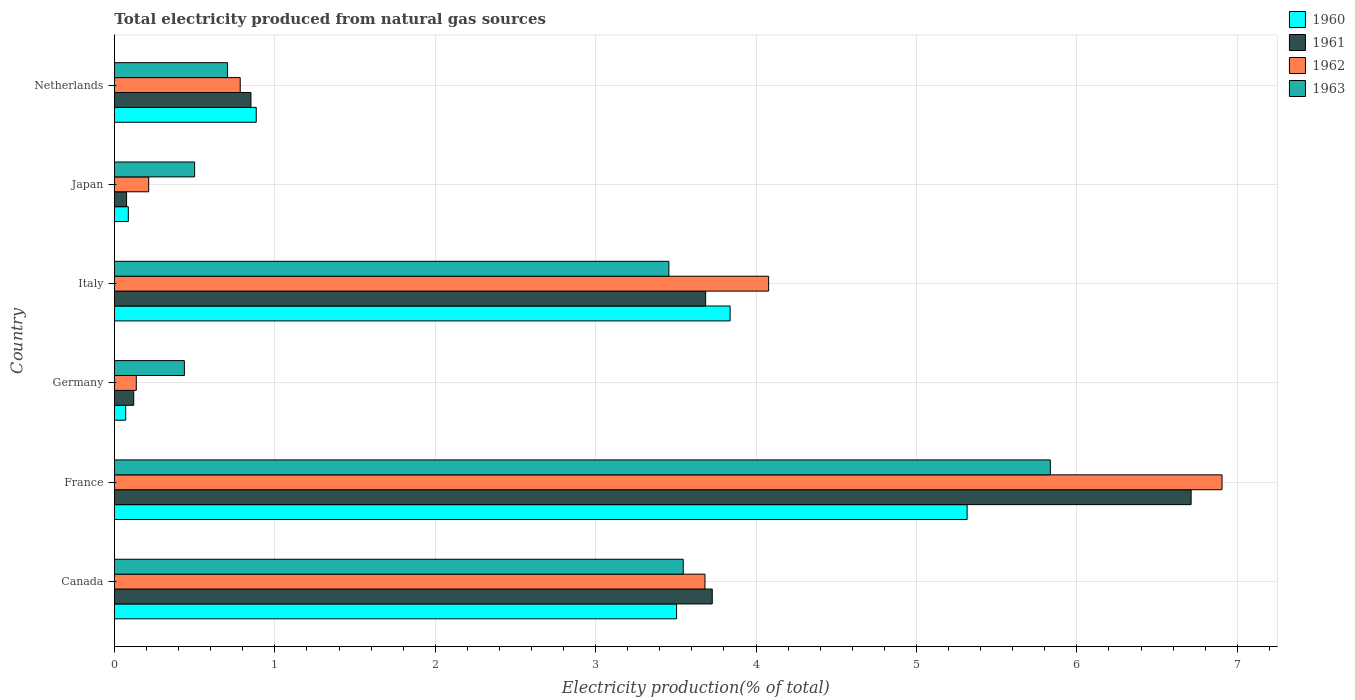How many groups of bars are there?
Your response must be concise. 6. Are the number of bars per tick equal to the number of legend labels?
Make the answer very short. Yes. Are the number of bars on each tick of the Y-axis equal?
Ensure brevity in your answer.  Yes. What is the total electricity produced in 1961 in France?
Make the answer very short. 6.71. Across all countries, what is the maximum total electricity produced in 1960?
Offer a terse response. 5.32. Across all countries, what is the minimum total electricity produced in 1962?
Provide a succinct answer. 0.14. In which country was the total electricity produced in 1960 maximum?
Make the answer very short. France. In which country was the total electricity produced in 1963 minimum?
Provide a short and direct response. Germany. What is the total total electricity produced in 1963 in the graph?
Provide a succinct answer. 14.48. What is the difference between the total electricity produced in 1962 in France and that in Italy?
Provide a short and direct response. 2.83. What is the difference between the total electricity produced in 1963 in France and the total electricity produced in 1961 in Canada?
Your answer should be very brief. 2.11. What is the average total electricity produced in 1961 per country?
Give a very brief answer. 2.53. What is the difference between the total electricity produced in 1960 and total electricity produced in 1962 in Japan?
Provide a succinct answer. -0.13. What is the ratio of the total electricity produced in 1961 in Germany to that in Netherlands?
Make the answer very short. 0.14. Is the total electricity produced in 1962 in Canada less than that in France?
Provide a short and direct response. Yes. Is the difference between the total electricity produced in 1960 in Canada and Italy greater than the difference between the total electricity produced in 1962 in Canada and Italy?
Make the answer very short. Yes. What is the difference between the highest and the second highest total electricity produced in 1960?
Your answer should be compact. 1.48. What is the difference between the highest and the lowest total electricity produced in 1963?
Provide a short and direct response. 5.4. What does the 4th bar from the top in Italy represents?
Your response must be concise. 1960. Are all the bars in the graph horizontal?
Your answer should be compact. Yes. Does the graph contain any zero values?
Provide a short and direct response. No. Where does the legend appear in the graph?
Provide a succinct answer. Top right. How many legend labels are there?
Provide a short and direct response. 4. How are the legend labels stacked?
Provide a succinct answer. Vertical. What is the title of the graph?
Keep it short and to the point. Total electricity produced from natural gas sources. Does "1994" appear as one of the legend labels in the graph?
Ensure brevity in your answer.  No. What is the label or title of the X-axis?
Make the answer very short. Electricity production(% of total). What is the label or title of the Y-axis?
Keep it short and to the point. Country. What is the Electricity production(% of total) in 1960 in Canada?
Your response must be concise. 3.5. What is the Electricity production(% of total) in 1961 in Canada?
Offer a terse response. 3.73. What is the Electricity production(% of total) in 1962 in Canada?
Your answer should be very brief. 3.68. What is the Electricity production(% of total) of 1963 in Canada?
Offer a very short reply. 3.55. What is the Electricity production(% of total) in 1960 in France?
Give a very brief answer. 5.32. What is the Electricity production(% of total) in 1961 in France?
Your response must be concise. 6.71. What is the Electricity production(% of total) in 1962 in France?
Keep it short and to the point. 6.91. What is the Electricity production(% of total) in 1963 in France?
Offer a terse response. 5.83. What is the Electricity production(% of total) in 1960 in Germany?
Provide a short and direct response. 0.07. What is the Electricity production(% of total) in 1961 in Germany?
Your answer should be compact. 0.12. What is the Electricity production(% of total) in 1962 in Germany?
Make the answer very short. 0.14. What is the Electricity production(% of total) of 1963 in Germany?
Your answer should be very brief. 0.44. What is the Electricity production(% of total) in 1960 in Italy?
Your response must be concise. 3.84. What is the Electricity production(% of total) in 1961 in Italy?
Your answer should be compact. 3.69. What is the Electricity production(% of total) in 1962 in Italy?
Keep it short and to the point. 4.08. What is the Electricity production(% of total) in 1963 in Italy?
Offer a terse response. 3.46. What is the Electricity production(% of total) of 1960 in Japan?
Keep it short and to the point. 0.09. What is the Electricity production(% of total) of 1961 in Japan?
Offer a terse response. 0.08. What is the Electricity production(% of total) in 1962 in Japan?
Provide a short and direct response. 0.21. What is the Electricity production(% of total) of 1963 in Japan?
Give a very brief answer. 0.5. What is the Electricity production(% of total) of 1960 in Netherlands?
Ensure brevity in your answer.  0.88. What is the Electricity production(% of total) of 1961 in Netherlands?
Provide a short and direct response. 0.85. What is the Electricity production(% of total) in 1962 in Netherlands?
Offer a very short reply. 0.78. What is the Electricity production(% of total) of 1963 in Netherlands?
Provide a short and direct response. 0.71. Across all countries, what is the maximum Electricity production(% of total) of 1960?
Ensure brevity in your answer.  5.32. Across all countries, what is the maximum Electricity production(% of total) of 1961?
Your response must be concise. 6.71. Across all countries, what is the maximum Electricity production(% of total) in 1962?
Your response must be concise. 6.91. Across all countries, what is the maximum Electricity production(% of total) in 1963?
Your response must be concise. 5.83. Across all countries, what is the minimum Electricity production(% of total) in 1960?
Make the answer very short. 0.07. Across all countries, what is the minimum Electricity production(% of total) in 1961?
Provide a succinct answer. 0.08. Across all countries, what is the minimum Electricity production(% of total) in 1962?
Ensure brevity in your answer.  0.14. Across all countries, what is the minimum Electricity production(% of total) in 1963?
Offer a very short reply. 0.44. What is the total Electricity production(% of total) of 1960 in the graph?
Keep it short and to the point. 13.7. What is the total Electricity production(% of total) of 1961 in the graph?
Offer a very short reply. 15.17. What is the total Electricity production(% of total) in 1962 in the graph?
Keep it short and to the point. 15.8. What is the total Electricity production(% of total) of 1963 in the graph?
Your answer should be very brief. 14.48. What is the difference between the Electricity production(% of total) in 1960 in Canada and that in France?
Your response must be concise. -1.81. What is the difference between the Electricity production(% of total) in 1961 in Canada and that in France?
Make the answer very short. -2.99. What is the difference between the Electricity production(% of total) in 1962 in Canada and that in France?
Provide a succinct answer. -3.22. What is the difference between the Electricity production(% of total) in 1963 in Canada and that in France?
Ensure brevity in your answer.  -2.29. What is the difference between the Electricity production(% of total) of 1960 in Canada and that in Germany?
Offer a very short reply. 3.43. What is the difference between the Electricity production(% of total) in 1961 in Canada and that in Germany?
Give a very brief answer. 3.61. What is the difference between the Electricity production(% of total) of 1962 in Canada and that in Germany?
Offer a terse response. 3.55. What is the difference between the Electricity production(% of total) of 1963 in Canada and that in Germany?
Make the answer very short. 3.11. What is the difference between the Electricity production(% of total) in 1960 in Canada and that in Italy?
Keep it short and to the point. -0.33. What is the difference between the Electricity production(% of total) in 1961 in Canada and that in Italy?
Your response must be concise. 0.04. What is the difference between the Electricity production(% of total) of 1962 in Canada and that in Italy?
Provide a succinct answer. -0.4. What is the difference between the Electricity production(% of total) of 1963 in Canada and that in Italy?
Offer a very short reply. 0.09. What is the difference between the Electricity production(% of total) of 1960 in Canada and that in Japan?
Offer a terse response. 3.42. What is the difference between the Electricity production(% of total) of 1961 in Canada and that in Japan?
Make the answer very short. 3.65. What is the difference between the Electricity production(% of total) in 1962 in Canada and that in Japan?
Your answer should be compact. 3.47. What is the difference between the Electricity production(% of total) in 1963 in Canada and that in Japan?
Your response must be concise. 3.05. What is the difference between the Electricity production(% of total) in 1960 in Canada and that in Netherlands?
Provide a short and direct response. 2.62. What is the difference between the Electricity production(% of total) in 1961 in Canada and that in Netherlands?
Your response must be concise. 2.88. What is the difference between the Electricity production(% of total) in 1962 in Canada and that in Netherlands?
Offer a very short reply. 2.9. What is the difference between the Electricity production(% of total) in 1963 in Canada and that in Netherlands?
Make the answer very short. 2.84. What is the difference between the Electricity production(% of total) in 1960 in France and that in Germany?
Your answer should be compact. 5.25. What is the difference between the Electricity production(% of total) of 1961 in France and that in Germany?
Offer a very short reply. 6.59. What is the difference between the Electricity production(% of total) in 1962 in France and that in Germany?
Ensure brevity in your answer.  6.77. What is the difference between the Electricity production(% of total) in 1963 in France and that in Germany?
Make the answer very short. 5.4. What is the difference between the Electricity production(% of total) in 1960 in France and that in Italy?
Keep it short and to the point. 1.48. What is the difference between the Electricity production(% of total) of 1961 in France and that in Italy?
Offer a very short reply. 3.03. What is the difference between the Electricity production(% of total) of 1962 in France and that in Italy?
Give a very brief answer. 2.83. What is the difference between the Electricity production(% of total) of 1963 in France and that in Italy?
Your answer should be very brief. 2.38. What is the difference between the Electricity production(% of total) in 1960 in France and that in Japan?
Give a very brief answer. 5.23. What is the difference between the Electricity production(% of total) in 1961 in France and that in Japan?
Give a very brief answer. 6.64. What is the difference between the Electricity production(% of total) of 1962 in France and that in Japan?
Offer a very short reply. 6.69. What is the difference between the Electricity production(% of total) of 1963 in France and that in Japan?
Keep it short and to the point. 5.33. What is the difference between the Electricity production(% of total) of 1960 in France and that in Netherlands?
Make the answer very short. 4.43. What is the difference between the Electricity production(% of total) in 1961 in France and that in Netherlands?
Your response must be concise. 5.86. What is the difference between the Electricity production(% of total) in 1962 in France and that in Netherlands?
Your answer should be compact. 6.12. What is the difference between the Electricity production(% of total) in 1963 in France and that in Netherlands?
Your response must be concise. 5.13. What is the difference between the Electricity production(% of total) of 1960 in Germany and that in Italy?
Your answer should be compact. -3.77. What is the difference between the Electricity production(% of total) of 1961 in Germany and that in Italy?
Your response must be concise. -3.57. What is the difference between the Electricity production(% of total) in 1962 in Germany and that in Italy?
Your answer should be compact. -3.94. What is the difference between the Electricity production(% of total) of 1963 in Germany and that in Italy?
Your answer should be compact. -3.02. What is the difference between the Electricity production(% of total) of 1960 in Germany and that in Japan?
Offer a very short reply. -0.02. What is the difference between the Electricity production(% of total) in 1961 in Germany and that in Japan?
Keep it short and to the point. 0.04. What is the difference between the Electricity production(% of total) in 1962 in Germany and that in Japan?
Your response must be concise. -0.08. What is the difference between the Electricity production(% of total) of 1963 in Germany and that in Japan?
Give a very brief answer. -0.06. What is the difference between the Electricity production(% of total) of 1960 in Germany and that in Netherlands?
Provide a short and direct response. -0.81. What is the difference between the Electricity production(% of total) in 1961 in Germany and that in Netherlands?
Your response must be concise. -0.73. What is the difference between the Electricity production(% of total) in 1962 in Germany and that in Netherlands?
Your answer should be very brief. -0.65. What is the difference between the Electricity production(% of total) in 1963 in Germany and that in Netherlands?
Ensure brevity in your answer.  -0.27. What is the difference between the Electricity production(% of total) in 1960 in Italy and that in Japan?
Your response must be concise. 3.75. What is the difference between the Electricity production(% of total) of 1961 in Italy and that in Japan?
Give a very brief answer. 3.61. What is the difference between the Electricity production(% of total) of 1962 in Italy and that in Japan?
Keep it short and to the point. 3.86. What is the difference between the Electricity production(% of total) in 1963 in Italy and that in Japan?
Keep it short and to the point. 2.96. What is the difference between the Electricity production(% of total) in 1960 in Italy and that in Netherlands?
Your response must be concise. 2.95. What is the difference between the Electricity production(% of total) of 1961 in Italy and that in Netherlands?
Keep it short and to the point. 2.83. What is the difference between the Electricity production(% of total) in 1962 in Italy and that in Netherlands?
Offer a terse response. 3.29. What is the difference between the Electricity production(% of total) of 1963 in Italy and that in Netherlands?
Ensure brevity in your answer.  2.75. What is the difference between the Electricity production(% of total) in 1960 in Japan and that in Netherlands?
Offer a very short reply. -0.8. What is the difference between the Electricity production(% of total) in 1961 in Japan and that in Netherlands?
Your answer should be very brief. -0.78. What is the difference between the Electricity production(% of total) in 1962 in Japan and that in Netherlands?
Your answer should be very brief. -0.57. What is the difference between the Electricity production(% of total) in 1963 in Japan and that in Netherlands?
Give a very brief answer. -0.21. What is the difference between the Electricity production(% of total) of 1960 in Canada and the Electricity production(% of total) of 1961 in France?
Your answer should be compact. -3.21. What is the difference between the Electricity production(% of total) of 1960 in Canada and the Electricity production(% of total) of 1962 in France?
Offer a terse response. -3.4. What is the difference between the Electricity production(% of total) of 1960 in Canada and the Electricity production(% of total) of 1963 in France?
Your response must be concise. -2.33. What is the difference between the Electricity production(% of total) in 1961 in Canada and the Electricity production(% of total) in 1962 in France?
Give a very brief answer. -3.18. What is the difference between the Electricity production(% of total) of 1961 in Canada and the Electricity production(% of total) of 1963 in France?
Ensure brevity in your answer.  -2.11. What is the difference between the Electricity production(% of total) in 1962 in Canada and the Electricity production(% of total) in 1963 in France?
Ensure brevity in your answer.  -2.15. What is the difference between the Electricity production(% of total) in 1960 in Canada and the Electricity production(% of total) in 1961 in Germany?
Provide a short and direct response. 3.38. What is the difference between the Electricity production(% of total) in 1960 in Canada and the Electricity production(% of total) in 1962 in Germany?
Provide a short and direct response. 3.37. What is the difference between the Electricity production(% of total) in 1960 in Canada and the Electricity production(% of total) in 1963 in Germany?
Your answer should be compact. 3.07. What is the difference between the Electricity production(% of total) in 1961 in Canada and the Electricity production(% of total) in 1962 in Germany?
Provide a succinct answer. 3.59. What is the difference between the Electricity production(% of total) in 1961 in Canada and the Electricity production(% of total) in 1963 in Germany?
Make the answer very short. 3.29. What is the difference between the Electricity production(% of total) in 1962 in Canada and the Electricity production(% of total) in 1963 in Germany?
Ensure brevity in your answer.  3.25. What is the difference between the Electricity production(% of total) of 1960 in Canada and the Electricity production(% of total) of 1961 in Italy?
Your answer should be compact. -0.18. What is the difference between the Electricity production(% of total) of 1960 in Canada and the Electricity production(% of total) of 1962 in Italy?
Your answer should be compact. -0.57. What is the difference between the Electricity production(% of total) in 1960 in Canada and the Electricity production(% of total) in 1963 in Italy?
Your answer should be compact. 0.05. What is the difference between the Electricity production(% of total) of 1961 in Canada and the Electricity production(% of total) of 1962 in Italy?
Make the answer very short. -0.35. What is the difference between the Electricity production(% of total) of 1961 in Canada and the Electricity production(% of total) of 1963 in Italy?
Offer a very short reply. 0.27. What is the difference between the Electricity production(% of total) in 1962 in Canada and the Electricity production(% of total) in 1963 in Italy?
Give a very brief answer. 0.23. What is the difference between the Electricity production(% of total) of 1960 in Canada and the Electricity production(% of total) of 1961 in Japan?
Ensure brevity in your answer.  3.43. What is the difference between the Electricity production(% of total) of 1960 in Canada and the Electricity production(% of total) of 1962 in Japan?
Your answer should be compact. 3.29. What is the difference between the Electricity production(% of total) of 1960 in Canada and the Electricity production(% of total) of 1963 in Japan?
Ensure brevity in your answer.  3. What is the difference between the Electricity production(% of total) of 1961 in Canada and the Electricity production(% of total) of 1962 in Japan?
Ensure brevity in your answer.  3.51. What is the difference between the Electricity production(% of total) of 1961 in Canada and the Electricity production(% of total) of 1963 in Japan?
Your answer should be very brief. 3.23. What is the difference between the Electricity production(% of total) in 1962 in Canada and the Electricity production(% of total) in 1963 in Japan?
Give a very brief answer. 3.18. What is the difference between the Electricity production(% of total) in 1960 in Canada and the Electricity production(% of total) in 1961 in Netherlands?
Provide a succinct answer. 2.65. What is the difference between the Electricity production(% of total) of 1960 in Canada and the Electricity production(% of total) of 1962 in Netherlands?
Provide a succinct answer. 2.72. What is the difference between the Electricity production(% of total) in 1960 in Canada and the Electricity production(% of total) in 1963 in Netherlands?
Your answer should be very brief. 2.8. What is the difference between the Electricity production(% of total) in 1961 in Canada and the Electricity production(% of total) in 1962 in Netherlands?
Your response must be concise. 2.94. What is the difference between the Electricity production(% of total) in 1961 in Canada and the Electricity production(% of total) in 1963 in Netherlands?
Give a very brief answer. 3.02. What is the difference between the Electricity production(% of total) in 1962 in Canada and the Electricity production(% of total) in 1963 in Netherlands?
Your answer should be compact. 2.98. What is the difference between the Electricity production(% of total) of 1960 in France and the Electricity production(% of total) of 1961 in Germany?
Provide a succinct answer. 5.2. What is the difference between the Electricity production(% of total) of 1960 in France and the Electricity production(% of total) of 1962 in Germany?
Provide a succinct answer. 5.18. What is the difference between the Electricity production(% of total) of 1960 in France and the Electricity production(% of total) of 1963 in Germany?
Your answer should be very brief. 4.88. What is the difference between the Electricity production(% of total) of 1961 in France and the Electricity production(% of total) of 1962 in Germany?
Ensure brevity in your answer.  6.58. What is the difference between the Electricity production(% of total) in 1961 in France and the Electricity production(% of total) in 1963 in Germany?
Keep it short and to the point. 6.28. What is the difference between the Electricity production(% of total) of 1962 in France and the Electricity production(% of total) of 1963 in Germany?
Offer a very short reply. 6.47. What is the difference between the Electricity production(% of total) in 1960 in France and the Electricity production(% of total) in 1961 in Italy?
Ensure brevity in your answer.  1.63. What is the difference between the Electricity production(% of total) in 1960 in France and the Electricity production(% of total) in 1962 in Italy?
Make the answer very short. 1.24. What is the difference between the Electricity production(% of total) in 1960 in France and the Electricity production(% of total) in 1963 in Italy?
Ensure brevity in your answer.  1.86. What is the difference between the Electricity production(% of total) of 1961 in France and the Electricity production(% of total) of 1962 in Italy?
Ensure brevity in your answer.  2.63. What is the difference between the Electricity production(% of total) of 1961 in France and the Electricity production(% of total) of 1963 in Italy?
Your answer should be compact. 3.26. What is the difference between the Electricity production(% of total) of 1962 in France and the Electricity production(% of total) of 1963 in Italy?
Keep it short and to the point. 3.45. What is the difference between the Electricity production(% of total) of 1960 in France and the Electricity production(% of total) of 1961 in Japan?
Keep it short and to the point. 5.24. What is the difference between the Electricity production(% of total) of 1960 in France and the Electricity production(% of total) of 1962 in Japan?
Ensure brevity in your answer.  5.1. What is the difference between the Electricity production(% of total) of 1960 in France and the Electricity production(% of total) of 1963 in Japan?
Give a very brief answer. 4.82. What is the difference between the Electricity production(% of total) in 1961 in France and the Electricity production(% of total) in 1962 in Japan?
Ensure brevity in your answer.  6.5. What is the difference between the Electricity production(% of total) of 1961 in France and the Electricity production(% of total) of 1963 in Japan?
Offer a very short reply. 6.21. What is the difference between the Electricity production(% of total) in 1962 in France and the Electricity production(% of total) in 1963 in Japan?
Give a very brief answer. 6.4. What is the difference between the Electricity production(% of total) in 1960 in France and the Electricity production(% of total) in 1961 in Netherlands?
Ensure brevity in your answer.  4.46. What is the difference between the Electricity production(% of total) in 1960 in France and the Electricity production(% of total) in 1962 in Netherlands?
Your response must be concise. 4.53. What is the difference between the Electricity production(% of total) of 1960 in France and the Electricity production(% of total) of 1963 in Netherlands?
Ensure brevity in your answer.  4.61. What is the difference between the Electricity production(% of total) in 1961 in France and the Electricity production(% of total) in 1962 in Netherlands?
Your response must be concise. 5.93. What is the difference between the Electricity production(% of total) in 1961 in France and the Electricity production(% of total) in 1963 in Netherlands?
Your response must be concise. 6.01. What is the difference between the Electricity production(% of total) in 1962 in France and the Electricity production(% of total) in 1963 in Netherlands?
Offer a terse response. 6.2. What is the difference between the Electricity production(% of total) of 1960 in Germany and the Electricity production(% of total) of 1961 in Italy?
Ensure brevity in your answer.  -3.62. What is the difference between the Electricity production(% of total) in 1960 in Germany and the Electricity production(% of total) in 1962 in Italy?
Your answer should be very brief. -4.01. What is the difference between the Electricity production(% of total) in 1960 in Germany and the Electricity production(% of total) in 1963 in Italy?
Your answer should be compact. -3.39. What is the difference between the Electricity production(% of total) of 1961 in Germany and the Electricity production(% of total) of 1962 in Italy?
Your answer should be compact. -3.96. What is the difference between the Electricity production(% of total) of 1961 in Germany and the Electricity production(% of total) of 1963 in Italy?
Your answer should be very brief. -3.34. What is the difference between the Electricity production(% of total) of 1962 in Germany and the Electricity production(% of total) of 1963 in Italy?
Your response must be concise. -3.32. What is the difference between the Electricity production(% of total) of 1960 in Germany and the Electricity production(% of total) of 1961 in Japan?
Provide a short and direct response. -0.01. What is the difference between the Electricity production(% of total) in 1960 in Germany and the Electricity production(% of total) in 1962 in Japan?
Your answer should be compact. -0.14. What is the difference between the Electricity production(% of total) of 1960 in Germany and the Electricity production(% of total) of 1963 in Japan?
Your answer should be compact. -0.43. What is the difference between the Electricity production(% of total) of 1961 in Germany and the Electricity production(% of total) of 1962 in Japan?
Ensure brevity in your answer.  -0.09. What is the difference between the Electricity production(% of total) in 1961 in Germany and the Electricity production(% of total) in 1963 in Japan?
Offer a very short reply. -0.38. What is the difference between the Electricity production(% of total) in 1962 in Germany and the Electricity production(% of total) in 1963 in Japan?
Make the answer very short. -0.36. What is the difference between the Electricity production(% of total) in 1960 in Germany and the Electricity production(% of total) in 1961 in Netherlands?
Make the answer very short. -0.78. What is the difference between the Electricity production(% of total) in 1960 in Germany and the Electricity production(% of total) in 1962 in Netherlands?
Offer a very short reply. -0.71. What is the difference between the Electricity production(% of total) in 1960 in Germany and the Electricity production(% of total) in 1963 in Netherlands?
Your answer should be compact. -0.64. What is the difference between the Electricity production(% of total) in 1961 in Germany and the Electricity production(% of total) in 1962 in Netherlands?
Your answer should be very brief. -0.66. What is the difference between the Electricity production(% of total) in 1961 in Germany and the Electricity production(% of total) in 1963 in Netherlands?
Provide a succinct answer. -0.58. What is the difference between the Electricity production(% of total) of 1962 in Germany and the Electricity production(% of total) of 1963 in Netherlands?
Offer a terse response. -0.57. What is the difference between the Electricity production(% of total) in 1960 in Italy and the Electricity production(% of total) in 1961 in Japan?
Offer a very short reply. 3.76. What is the difference between the Electricity production(% of total) of 1960 in Italy and the Electricity production(% of total) of 1962 in Japan?
Offer a very short reply. 3.62. What is the difference between the Electricity production(% of total) in 1960 in Italy and the Electricity production(% of total) in 1963 in Japan?
Give a very brief answer. 3.34. What is the difference between the Electricity production(% of total) in 1961 in Italy and the Electricity production(% of total) in 1962 in Japan?
Ensure brevity in your answer.  3.47. What is the difference between the Electricity production(% of total) of 1961 in Italy and the Electricity production(% of total) of 1963 in Japan?
Make the answer very short. 3.19. What is the difference between the Electricity production(% of total) in 1962 in Italy and the Electricity production(% of total) in 1963 in Japan?
Your answer should be very brief. 3.58. What is the difference between the Electricity production(% of total) in 1960 in Italy and the Electricity production(% of total) in 1961 in Netherlands?
Your answer should be very brief. 2.99. What is the difference between the Electricity production(% of total) in 1960 in Italy and the Electricity production(% of total) in 1962 in Netherlands?
Provide a short and direct response. 3.05. What is the difference between the Electricity production(% of total) of 1960 in Italy and the Electricity production(% of total) of 1963 in Netherlands?
Offer a terse response. 3.13. What is the difference between the Electricity production(% of total) of 1961 in Italy and the Electricity production(% of total) of 1962 in Netherlands?
Your answer should be very brief. 2.9. What is the difference between the Electricity production(% of total) in 1961 in Italy and the Electricity production(% of total) in 1963 in Netherlands?
Give a very brief answer. 2.98. What is the difference between the Electricity production(% of total) in 1962 in Italy and the Electricity production(% of total) in 1963 in Netherlands?
Give a very brief answer. 3.37. What is the difference between the Electricity production(% of total) in 1960 in Japan and the Electricity production(% of total) in 1961 in Netherlands?
Keep it short and to the point. -0.76. What is the difference between the Electricity production(% of total) in 1960 in Japan and the Electricity production(% of total) in 1962 in Netherlands?
Make the answer very short. -0.7. What is the difference between the Electricity production(% of total) in 1960 in Japan and the Electricity production(% of total) in 1963 in Netherlands?
Keep it short and to the point. -0.62. What is the difference between the Electricity production(% of total) of 1961 in Japan and the Electricity production(% of total) of 1962 in Netherlands?
Your answer should be compact. -0.71. What is the difference between the Electricity production(% of total) in 1961 in Japan and the Electricity production(% of total) in 1963 in Netherlands?
Your response must be concise. -0.63. What is the difference between the Electricity production(% of total) in 1962 in Japan and the Electricity production(% of total) in 1963 in Netherlands?
Ensure brevity in your answer.  -0.49. What is the average Electricity production(% of total) of 1960 per country?
Provide a short and direct response. 2.28. What is the average Electricity production(% of total) of 1961 per country?
Give a very brief answer. 2.53. What is the average Electricity production(% of total) in 1962 per country?
Ensure brevity in your answer.  2.63. What is the average Electricity production(% of total) in 1963 per country?
Provide a succinct answer. 2.41. What is the difference between the Electricity production(% of total) in 1960 and Electricity production(% of total) in 1961 in Canada?
Make the answer very short. -0.22. What is the difference between the Electricity production(% of total) of 1960 and Electricity production(% of total) of 1962 in Canada?
Ensure brevity in your answer.  -0.18. What is the difference between the Electricity production(% of total) of 1960 and Electricity production(% of total) of 1963 in Canada?
Keep it short and to the point. -0.04. What is the difference between the Electricity production(% of total) in 1961 and Electricity production(% of total) in 1962 in Canada?
Provide a short and direct response. 0.05. What is the difference between the Electricity production(% of total) in 1961 and Electricity production(% of total) in 1963 in Canada?
Your response must be concise. 0.18. What is the difference between the Electricity production(% of total) in 1962 and Electricity production(% of total) in 1963 in Canada?
Your answer should be very brief. 0.14. What is the difference between the Electricity production(% of total) in 1960 and Electricity production(% of total) in 1961 in France?
Make the answer very short. -1.4. What is the difference between the Electricity production(% of total) of 1960 and Electricity production(% of total) of 1962 in France?
Make the answer very short. -1.59. What is the difference between the Electricity production(% of total) of 1960 and Electricity production(% of total) of 1963 in France?
Give a very brief answer. -0.52. What is the difference between the Electricity production(% of total) of 1961 and Electricity production(% of total) of 1962 in France?
Your answer should be compact. -0.19. What is the difference between the Electricity production(% of total) in 1961 and Electricity production(% of total) in 1963 in France?
Make the answer very short. 0.88. What is the difference between the Electricity production(% of total) in 1962 and Electricity production(% of total) in 1963 in France?
Offer a very short reply. 1.07. What is the difference between the Electricity production(% of total) in 1960 and Electricity production(% of total) in 1961 in Germany?
Offer a terse response. -0.05. What is the difference between the Electricity production(% of total) in 1960 and Electricity production(% of total) in 1962 in Germany?
Make the answer very short. -0.07. What is the difference between the Electricity production(% of total) of 1960 and Electricity production(% of total) of 1963 in Germany?
Keep it short and to the point. -0.37. What is the difference between the Electricity production(% of total) in 1961 and Electricity production(% of total) in 1962 in Germany?
Keep it short and to the point. -0.02. What is the difference between the Electricity production(% of total) of 1961 and Electricity production(% of total) of 1963 in Germany?
Provide a short and direct response. -0.32. What is the difference between the Electricity production(% of total) in 1962 and Electricity production(% of total) in 1963 in Germany?
Your response must be concise. -0.3. What is the difference between the Electricity production(% of total) in 1960 and Electricity production(% of total) in 1961 in Italy?
Give a very brief answer. 0.15. What is the difference between the Electricity production(% of total) in 1960 and Electricity production(% of total) in 1962 in Italy?
Provide a short and direct response. -0.24. What is the difference between the Electricity production(% of total) of 1960 and Electricity production(% of total) of 1963 in Italy?
Keep it short and to the point. 0.38. What is the difference between the Electricity production(% of total) of 1961 and Electricity production(% of total) of 1962 in Italy?
Your answer should be very brief. -0.39. What is the difference between the Electricity production(% of total) in 1961 and Electricity production(% of total) in 1963 in Italy?
Your answer should be compact. 0.23. What is the difference between the Electricity production(% of total) in 1962 and Electricity production(% of total) in 1963 in Italy?
Offer a terse response. 0.62. What is the difference between the Electricity production(% of total) of 1960 and Electricity production(% of total) of 1961 in Japan?
Provide a short and direct response. 0.01. What is the difference between the Electricity production(% of total) of 1960 and Electricity production(% of total) of 1962 in Japan?
Ensure brevity in your answer.  -0.13. What is the difference between the Electricity production(% of total) in 1960 and Electricity production(% of total) in 1963 in Japan?
Offer a terse response. -0.41. What is the difference between the Electricity production(% of total) of 1961 and Electricity production(% of total) of 1962 in Japan?
Provide a short and direct response. -0.14. What is the difference between the Electricity production(% of total) of 1961 and Electricity production(% of total) of 1963 in Japan?
Ensure brevity in your answer.  -0.42. What is the difference between the Electricity production(% of total) in 1962 and Electricity production(% of total) in 1963 in Japan?
Your answer should be compact. -0.29. What is the difference between the Electricity production(% of total) of 1960 and Electricity production(% of total) of 1961 in Netherlands?
Your answer should be compact. 0.03. What is the difference between the Electricity production(% of total) of 1960 and Electricity production(% of total) of 1962 in Netherlands?
Offer a terse response. 0.1. What is the difference between the Electricity production(% of total) in 1960 and Electricity production(% of total) in 1963 in Netherlands?
Your response must be concise. 0.18. What is the difference between the Electricity production(% of total) in 1961 and Electricity production(% of total) in 1962 in Netherlands?
Provide a short and direct response. 0.07. What is the difference between the Electricity production(% of total) of 1961 and Electricity production(% of total) of 1963 in Netherlands?
Give a very brief answer. 0.15. What is the difference between the Electricity production(% of total) of 1962 and Electricity production(% of total) of 1963 in Netherlands?
Provide a succinct answer. 0.08. What is the ratio of the Electricity production(% of total) in 1960 in Canada to that in France?
Provide a short and direct response. 0.66. What is the ratio of the Electricity production(% of total) in 1961 in Canada to that in France?
Your answer should be very brief. 0.56. What is the ratio of the Electricity production(% of total) in 1962 in Canada to that in France?
Give a very brief answer. 0.53. What is the ratio of the Electricity production(% of total) of 1963 in Canada to that in France?
Provide a succinct answer. 0.61. What is the ratio of the Electricity production(% of total) of 1960 in Canada to that in Germany?
Your response must be concise. 49.85. What is the ratio of the Electricity production(% of total) of 1961 in Canada to that in Germany?
Make the answer very short. 30.98. What is the ratio of the Electricity production(% of total) in 1962 in Canada to that in Germany?
Provide a succinct answer. 27.02. What is the ratio of the Electricity production(% of total) of 1963 in Canada to that in Germany?
Keep it short and to the point. 8.13. What is the ratio of the Electricity production(% of total) of 1960 in Canada to that in Italy?
Your response must be concise. 0.91. What is the ratio of the Electricity production(% of total) of 1961 in Canada to that in Italy?
Make the answer very short. 1.01. What is the ratio of the Electricity production(% of total) in 1962 in Canada to that in Italy?
Ensure brevity in your answer.  0.9. What is the ratio of the Electricity production(% of total) of 1963 in Canada to that in Italy?
Keep it short and to the point. 1.03. What is the ratio of the Electricity production(% of total) in 1960 in Canada to that in Japan?
Offer a very short reply. 40.48. What is the ratio of the Electricity production(% of total) of 1961 in Canada to that in Japan?
Ensure brevity in your answer.  49.23. What is the ratio of the Electricity production(% of total) of 1962 in Canada to that in Japan?
Give a very brief answer. 17.23. What is the ratio of the Electricity production(% of total) in 1963 in Canada to that in Japan?
Offer a terse response. 7.09. What is the ratio of the Electricity production(% of total) of 1960 in Canada to that in Netherlands?
Your answer should be very brief. 3.96. What is the ratio of the Electricity production(% of total) of 1961 in Canada to that in Netherlands?
Your answer should be compact. 4.38. What is the ratio of the Electricity production(% of total) of 1962 in Canada to that in Netherlands?
Your answer should be very brief. 4.69. What is the ratio of the Electricity production(% of total) of 1963 in Canada to that in Netherlands?
Provide a succinct answer. 5.03. What is the ratio of the Electricity production(% of total) in 1960 in France to that in Germany?
Offer a terse response. 75.62. What is the ratio of the Electricity production(% of total) of 1961 in France to that in Germany?
Make the answer very short. 55.79. What is the ratio of the Electricity production(% of total) of 1962 in France to that in Germany?
Ensure brevity in your answer.  50.69. What is the ratio of the Electricity production(% of total) in 1963 in France to that in Germany?
Your response must be concise. 13.38. What is the ratio of the Electricity production(% of total) of 1960 in France to that in Italy?
Your response must be concise. 1.39. What is the ratio of the Electricity production(% of total) of 1961 in France to that in Italy?
Offer a very short reply. 1.82. What is the ratio of the Electricity production(% of total) of 1962 in France to that in Italy?
Your answer should be very brief. 1.69. What is the ratio of the Electricity production(% of total) of 1963 in France to that in Italy?
Provide a short and direct response. 1.69. What is the ratio of the Electricity production(% of total) in 1960 in France to that in Japan?
Keep it short and to the point. 61.4. What is the ratio of the Electricity production(% of total) in 1961 in France to that in Japan?
Your answer should be compact. 88.67. What is the ratio of the Electricity production(% of total) in 1962 in France to that in Japan?
Ensure brevity in your answer.  32.32. What is the ratio of the Electricity production(% of total) in 1963 in France to that in Japan?
Offer a very short reply. 11.67. What is the ratio of the Electricity production(% of total) of 1960 in France to that in Netherlands?
Provide a short and direct response. 6.01. What is the ratio of the Electricity production(% of total) in 1961 in France to that in Netherlands?
Ensure brevity in your answer.  7.89. What is the ratio of the Electricity production(% of total) of 1962 in France to that in Netherlands?
Provide a succinct answer. 8.8. What is the ratio of the Electricity production(% of total) of 1963 in France to that in Netherlands?
Make the answer very short. 8.27. What is the ratio of the Electricity production(% of total) of 1960 in Germany to that in Italy?
Your response must be concise. 0.02. What is the ratio of the Electricity production(% of total) in 1961 in Germany to that in Italy?
Keep it short and to the point. 0.03. What is the ratio of the Electricity production(% of total) in 1962 in Germany to that in Italy?
Your answer should be compact. 0.03. What is the ratio of the Electricity production(% of total) in 1963 in Germany to that in Italy?
Keep it short and to the point. 0.13. What is the ratio of the Electricity production(% of total) of 1960 in Germany to that in Japan?
Make the answer very short. 0.81. What is the ratio of the Electricity production(% of total) of 1961 in Germany to that in Japan?
Keep it short and to the point. 1.59. What is the ratio of the Electricity production(% of total) in 1962 in Germany to that in Japan?
Your answer should be very brief. 0.64. What is the ratio of the Electricity production(% of total) in 1963 in Germany to that in Japan?
Your answer should be very brief. 0.87. What is the ratio of the Electricity production(% of total) of 1960 in Germany to that in Netherlands?
Ensure brevity in your answer.  0.08. What is the ratio of the Electricity production(% of total) of 1961 in Germany to that in Netherlands?
Your response must be concise. 0.14. What is the ratio of the Electricity production(% of total) of 1962 in Germany to that in Netherlands?
Offer a very short reply. 0.17. What is the ratio of the Electricity production(% of total) in 1963 in Germany to that in Netherlands?
Offer a terse response. 0.62. What is the ratio of the Electricity production(% of total) in 1960 in Italy to that in Japan?
Provide a succinct answer. 44.33. What is the ratio of the Electricity production(% of total) in 1961 in Italy to that in Japan?
Ensure brevity in your answer.  48.69. What is the ratio of the Electricity production(% of total) of 1962 in Italy to that in Japan?
Ensure brevity in your answer.  19.09. What is the ratio of the Electricity production(% of total) in 1963 in Italy to that in Japan?
Provide a succinct answer. 6.91. What is the ratio of the Electricity production(% of total) in 1960 in Italy to that in Netherlands?
Offer a very short reply. 4.34. What is the ratio of the Electricity production(% of total) in 1961 in Italy to that in Netherlands?
Offer a very short reply. 4.33. What is the ratio of the Electricity production(% of total) of 1962 in Italy to that in Netherlands?
Make the answer very short. 5.2. What is the ratio of the Electricity production(% of total) of 1963 in Italy to that in Netherlands?
Keep it short and to the point. 4.9. What is the ratio of the Electricity production(% of total) of 1960 in Japan to that in Netherlands?
Your response must be concise. 0.1. What is the ratio of the Electricity production(% of total) of 1961 in Japan to that in Netherlands?
Offer a terse response. 0.09. What is the ratio of the Electricity production(% of total) of 1962 in Japan to that in Netherlands?
Your answer should be very brief. 0.27. What is the ratio of the Electricity production(% of total) in 1963 in Japan to that in Netherlands?
Ensure brevity in your answer.  0.71. What is the difference between the highest and the second highest Electricity production(% of total) in 1960?
Your response must be concise. 1.48. What is the difference between the highest and the second highest Electricity production(% of total) of 1961?
Offer a very short reply. 2.99. What is the difference between the highest and the second highest Electricity production(% of total) in 1962?
Provide a succinct answer. 2.83. What is the difference between the highest and the second highest Electricity production(% of total) of 1963?
Ensure brevity in your answer.  2.29. What is the difference between the highest and the lowest Electricity production(% of total) of 1960?
Provide a short and direct response. 5.25. What is the difference between the highest and the lowest Electricity production(% of total) in 1961?
Provide a succinct answer. 6.64. What is the difference between the highest and the lowest Electricity production(% of total) in 1962?
Your answer should be compact. 6.77. What is the difference between the highest and the lowest Electricity production(% of total) of 1963?
Give a very brief answer. 5.4. 